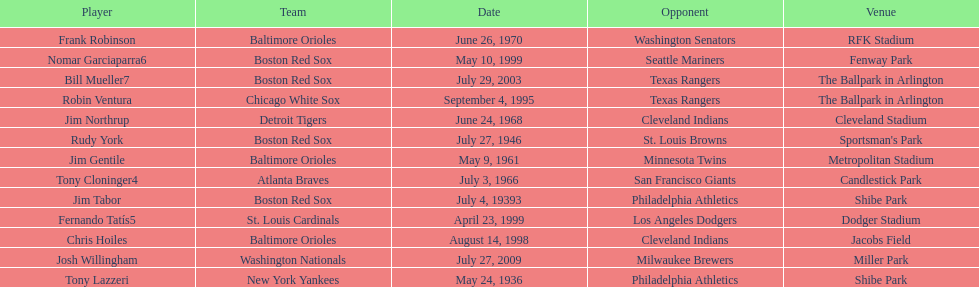Can you parse all the data within this table? {'header': ['Player', 'Team', 'Date', 'Opponent', 'Venue'], 'rows': [['Frank Robinson', 'Baltimore Orioles', 'June 26, 1970', 'Washington Senators', 'RFK Stadium'], ['Nomar Garciaparra6', 'Boston Red Sox', 'May 10, 1999', 'Seattle Mariners', 'Fenway Park'], ['Bill Mueller7', 'Boston Red Sox', 'July 29, 2003', 'Texas Rangers', 'The Ballpark in Arlington'], ['Robin Ventura', 'Chicago White Sox', 'September 4, 1995', 'Texas Rangers', 'The Ballpark in Arlington'], ['Jim Northrup', 'Detroit Tigers', 'June 24, 1968', 'Cleveland Indians', 'Cleveland Stadium'], ['Rudy York', 'Boston Red Sox', 'July 27, 1946', 'St. Louis Browns', "Sportsman's Park"], ['Jim Gentile', 'Baltimore Orioles', 'May 9, 1961', 'Minnesota Twins', 'Metropolitan Stadium'], ['Tony Cloninger4', 'Atlanta Braves', 'July 3, 1966', 'San Francisco Giants', 'Candlestick Park'], ['Jim Tabor', 'Boston Red Sox', 'July 4, 19393', 'Philadelphia Athletics', 'Shibe Park'], ['Fernando Tatís5', 'St. Louis Cardinals', 'April 23, 1999', 'Los Angeles Dodgers', 'Dodger Stadium'], ['Chris Hoiles', 'Baltimore Orioles', 'August 14, 1998', 'Cleveland Indians', 'Jacobs Field'], ['Josh Willingham', 'Washington Nationals', 'July 27, 2009', 'Milwaukee Brewers', 'Miller Park'], ['Tony Lazzeri', 'New York Yankees', 'May 24, 1936', 'Philadelphia Athletics', 'Shibe Park']]} Who is the first major league hitter to hit two grand slams in one game? Tony Lazzeri. 